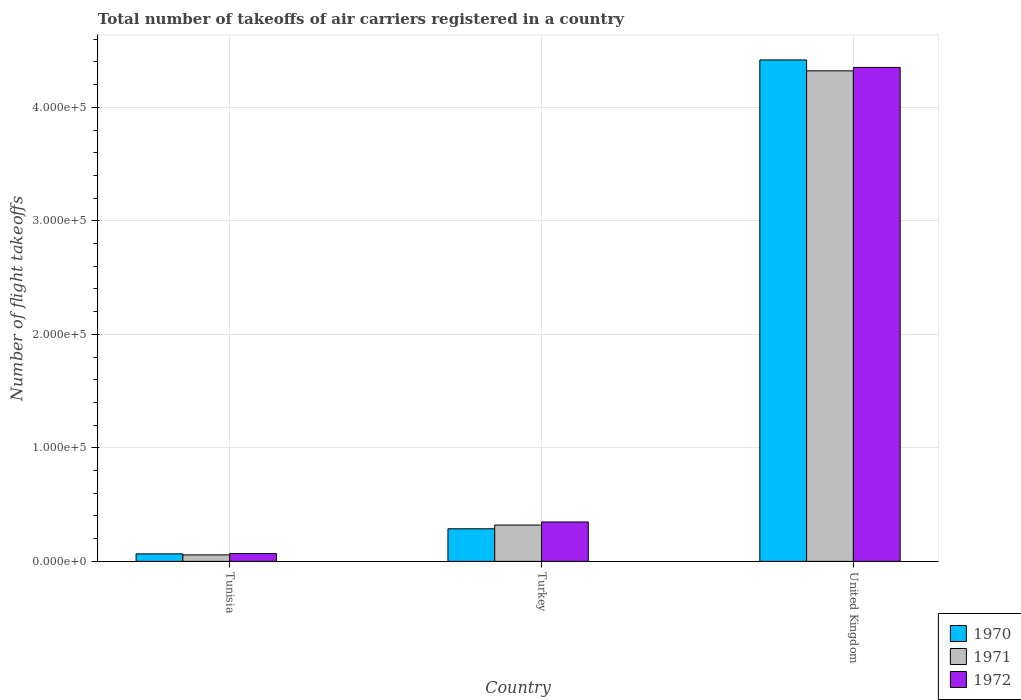How many different coloured bars are there?
Provide a short and direct response. 3. Are the number of bars per tick equal to the number of legend labels?
Your answer should be very brief. Yes. How many bars are there on the 1st tick from the left?
Keep it short and to the point. 3. What is the label of the 2nd group of bars from the left?
Offer a terse response. Turkey. In how many cases, is the number of bars for a given country not equal to the number of legend labels?
Your answer should be compact. 0. What is the total number of flight takeoffs in 1972 in Tunisia?
Offer a terse response. 6900. Across all countries, what is the maximum total number of flight takeoffs in 1970?
Provide a succinct answer. 4.42e+05. Across all countries, what is the minimum total number of flight takeoffs in 1971?
Provide a succinct answer. 5700. In which country was the total number of flight takeoffs in 1970 maximum?
Offer a terse response. United Kingdom. In which country was the total number of flight takeoffs in 1971 minimum?
Ensure brevity in your answer.  Tunisia. What is the total total number of flight takeoffs in 1970 in the graph?
Your response must be concise. 4.77e+05. What is the difference between the total number of flight takeoffs in 1971 in Turkey and that in United Kingdom?
Your answer should be compact. -4.00e+05. What is the difference between the total number of flight takeoffs in 1970 in Turkey and the total number of flight takeoffs in 1972 in United Kingdom?
Your answer should be very brief. -4.06e+05. What is the average total number of flight takeoffs in 1971 per country?
Your answer should be very brief. 1.57e+05. What is the difference between the total number of flight takeoffs of/in 1970 and total number of flight takeoffs of/in 1971 in United Kingdom?
Give a very brief answer. 9600. What is the ratio of the total number of flight takeoffs in 1971 in Tunisia to that in Turkey?
Give a very brief answer. 0.18. Is the total number of flight takeoffs in 1971 in Turkey less than that in United Kingdom?
Keep it short and to the point. Yes. Is the difference between the total number of flight takeoffs in 1970 in Tunisia and United Kingdom greater than the difference between the total number of flight takeoffs in 1971 in Tunisia and United Kingdom?
Your answer should be very brief. No. What is the difference between the highest and the second highest total number of flight takeoffs in 1970?
Make the answer very short. 4.13e+05. What is the difference between the highest and the lowest total number of flight takeoffs in 1971?
Offer a very short reply. 4.26e+05. In how many countries, is the total number of flight takeoffs in 1972 greater than the average total number of flight takeoffs in 1972 taken over all countries?
Your answer should be very brief. 1. Are all the bars in the graph horizontal?
Provide a short and direct response. No. How many countries are there in the graph?
Provide a short and direct response. 3. Are the values on the major ticks of Y-axis written in scientific E-notation?
Keep it short and to the point. Yes. How many legend labels are there?
Your answer should be compact. 3. How are the legend labels stacked?
Keep it short and to the point. Vertical. What is the title of the graph?
Keep it short and to the point. Total number of takeoffs of air carriers registered in a country. Does "2009" appear as one of the legend labels in the graph?
Your answer should be very brief. No. What is the label or title of the X-axis?
Make the answer very short. Country. What is the label or title of the Y-axis?
Ensure brevity in your answer.  Number of flight takeoffs. What is the Number of flight takeoffs of 1970 in Tunisia?
Your answer should be very brief. 6600. What is the Number of flight takeoffs in 1971 in Tunisia?
Offer a terse response. 5700. What is the Number of flight takeoffs of 1972 in Tunisia?
Your answer should be very brief. 6900. What is the Number of flight takeoffs of 1970 in Turkey?
Make the answer very short. 2.87e+04. What is the Number of flight takeoffs of 1971 in Turkey?
Your response must be concise. 3.20e+04. What is the Number of flight takeoffs in 1972 in Turkey?
Your response must be concise. 3.47e+04. What is the Number of flight takeoffs in 1970 in United Kingdom?
Give a very brief answer. 4.42e+05. What is the Number of flight takeoffs in 1971 in United Kingdom?
Offer a very short reply. 4.32e+05. What is the Number of flight takeoffs of 1972 in United Kingdom?
Offer a terse response. 4.35e+05. Across all countries, what is the maximum Number of flight takeoffs in 1970?
Your answer should be very brief. 4.42e+05. Across all countries, what is the maximum Number of flight takeoffs in 1971?
Give a very brief answer. 4.32e+05. Across all countries, what is the maximum Number of flight takeoffs in 1972?
Your answer should be compact. 4.35e+05. Across all countries, what is the minimum Number of flight takeoffs in 1970?
Make the answer very short. 6600. Across all countries, what is the minimum Number of flight takeoffs of 1971?
Your answer should be very brief. 5700. Across all countries, what is the minimum Number of flight takeoffs in 1972?
Give a very brief answer. 6900. What is the total Number of flight takeoffs of 1970 in the graph?
Ensure brevity in your answer.  4.77e+05. What is the total Number of flight takeoffs in 1971 in the graph?
Make the answer very short. 4.70e+05. What is the total Number of flight takeoffs of 1972 in the graph?
Offer a terse response. 4.77e+05. What is the difference between the Number of flight takeoffs of 1970 in Tunisia and that in Turkey?
Provide a succinct answer. -2.21e+04. What is the difference between the Number of flight takeoffs of 1971 in Tunisia and that in Turkey?
Provide a succinct answer. -2.63e+04. What is the difference between the Number of flight takeoffs in 1972 in Tunisia and that in Turkey?
Ensure brevity in your answer.  -2.78e+04. What is the difference between the Number of flight takeoffs in 1970 in Tunisia and that in United Kingdom?
Keep it short and to the point. -4.35e+05. What is the difference between the Number of flight takeoffs of 1971 in Tunisia and that in United Kingdom?
Keep it short and to the point. -4.26e+05. What is the difference between the Number of flight takeoffs of 1972 in Tunisia and that in United Kingdom?
Provide a succinct answer. -4.28e+05. What is the difference between the Number of flight takeoffs of 1970 in Turkey and that in United Kingdom?
Offer a very short reply. -4.13e+05. What is the difference between the Number of flight takeoffs of 1971 in Turkey and that in United Kingdom?
Your answer should be compact. -4.00e+05. What is the difference between the Number of flight takeoffs of 1972 in Turkey and that in United Kingdom?
Ensure brevity in your answer.  -4.00e+05. What is the difference between the Number of flight takeoffs in 1970 in Tunisia and the Number of flight takeoffs in 1971 in Turkey?
Provide a short and direct response. -2.54e+04. What is the difference between the Number of flight takeoffs in 1970 in Tunisia and the Number of flight takeoffs in 1972 in Turkey?
Your answer should be very brief. -2.81e+04. What is the difference between the Number of flight takeoffs in 1971 in Tunisia and the Number of flight takeoffs in 1972 in Turkey?
Ensure brevity in your answer.  -2.90e+04. What is the difference between the Number of flight takeoffs in 1970 in Tunisia and the Number of flight takeoffs in 1971 in United Kingdom?
Give a very brief answer. -4.26e+05. What is the difference between the Number of flight takeoffs in 1970 in Tunisia and the Number of flight takeoffs in 1972 in United Kingdom?
Your answer should be compact. -4.29e+05. What is the difference between the Number of flight takeoffs of 1971 in Tunisia and the Number of flight takeoffs of 1972 in United Kingdom?
Make the answer very short. -4.30e+05. What is the difference between the Number of flight takeoffs of 1970 in Turkey and the Number of flight takeoffs of 1971 in United Kingdom?
Your response must be concise. -4.04e+05. What is the difference between the Number of flight takeoffs of 1970 in Turkey and the Number of flight takeoffs of 1972 in United Kingdom?
Ensure brevity in your answer.  -4.06e+05. What is the difference between the Number of flight takeoffs in 1971 in Turkey and the Number of flight takeoffs in 1972 in United Kingdom?
Your response must be concise. -4.03e+05. What is the average Number of flight takeoffs of 1970 per country?
Make the answer very short. 1.59e+05. What is the average Number of flight takeoffs of 1971 per country?
Give a very brief answer. 1.57e+05. What is the average Number of flight takeoffs in 1972 per country?
Keep it short and to the point. 1.59e+05. What is the difference between the Number of flight takeoffs in 1970 and Number of flight takeoffs in 1971 in Tunisia?
Offer a terse response. 900. What is the difference between the Number of flight takeoffs in 1970 and Number of flight takeoffs in 1972 in Tunisia?
Your answer should be very brief. -300. What is the difference between the Number of flight takeoffs in 1971 and Number of flight takeoffs in 1972 in Tunisia?
Make the answer very short. -1200. What is the difference between the Number of flight takeoffs of 1970 and Number of flight takeoffs of 1971 in Turkey?
Your answer should be compact. -3300. What is the difference between the Number of flight takeoffs in 1970 and Number of flight takeoffs in 1972 in Turkey?
Keep it short and to the point. -6000. What is the difference between the Number of flight takeoffs in 1971 and Number of flight takeoffs in 1972 in Turkey?
Give a very brief answer. -2700. What is the difference between the Number of flight takeoffs of 1970 and Number of flight takeoffs of 1971 in United Kingdom?
Keep it short and to the point. 9600. What is the difference between the Number of flight takeoffs in 1970 and Number of flight takeoffs in 1972 in United Kingdom?
Provide a succinct answer. 6600. What is the difference between the Number of flight takeoffs in 1971 and Number of flight takeoffs in 1972 in United Kingdom?
Offer a very short reply. -3000. What is the ratio of the Number of flight takeoffs in 1970 in Tunisia to that in Turkey?
Ensure brevity in your answer.  0.23. What is the ratio of the Number of flight takeoffs of 1971 in Tunisia to that in Turkey?
Your response must be concise. 0.18. What is the ratio of the Number of flight takeoffs of 1972 in Tunisia to that in Turkey?
Your answer should be very brief. 0.2. What is the ratio of the Number of flight takeoffs of 1970 in Tunisia to that in United Kingdom?
Provide a succinct answer. 0.01. What is the ratio of the Number of flight takeoffs in 1971 in Tunisia to that in United Kingdom?
Keep it short and to the point. 0.01. What is the ratio of the Number of flight takeoffs of 1972 in Tunisia to that in United Kingdom?
Your response must be concise. 0.02. What is the ratio of the Number of flight takeoffs in 1970 in Turkey to that in United Kingdom?
Offer a very short reply. 0.07. What is the ratio of the Number of flight takeoffs in 1971 in Turkey to that in United Kingdom?
Offer a terse response. 0.07. What is the ratio of the Number of flight takeoffs of 1972 in Turkey to that in United Kingdom?
Give a very brief answer. 0.08. What is the difference between the highest and the second highest Number of flight takeoffs in 1970?
Your response must be concise. 4.13e+05. What is the difference between the highest and the second highest Number of flight takeoffs in 1971?
Offer a very short reply. 4.00e+05. What is the difference between the highest and the second highest Number of flight takeoffs of 1972?
Provide a short and direct response. 4.00e+05. What is the difference between the highest and the lowest Number of flight takeoffs in 1970?
Provide a succinct answer. 4.35e+05. What is the difference between the highest and the lowest Number of flight takeoffs of 1971?
Ensure brevity in your answer.  4.26e+05. What is the difference between the highest and the lowest Number of flight takeoffs of 1972?
Provide a short and direct response. 4.28e+05. 